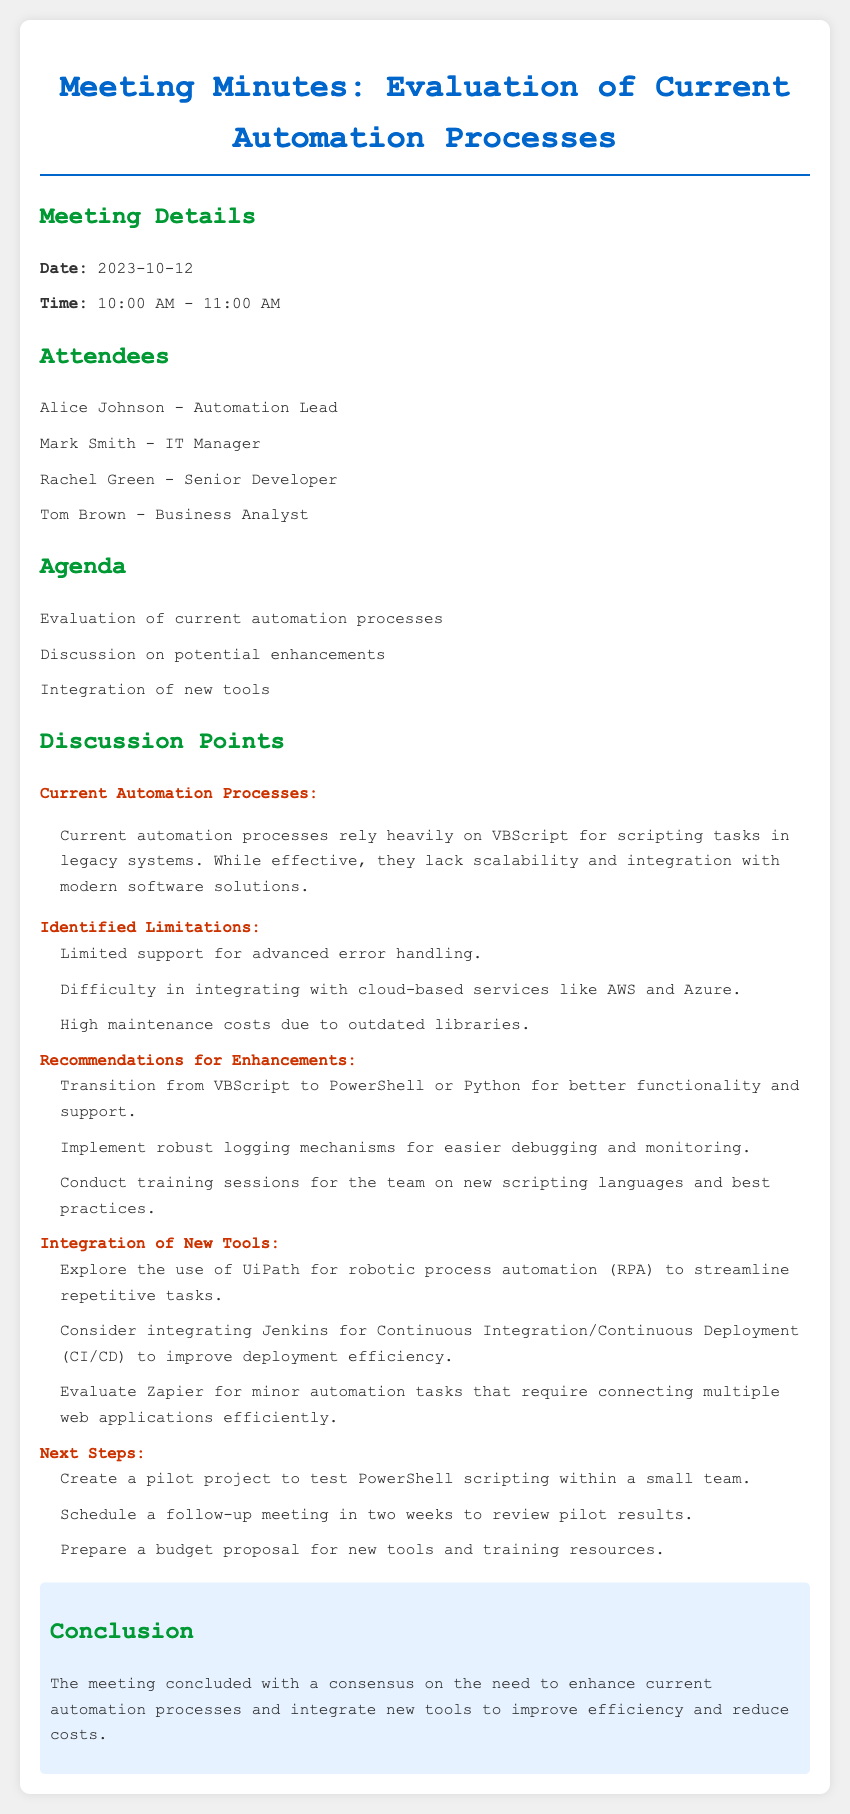what was the date of the meeting? The date of the meeting is specified in the document under Meeting Details.
Answer: 2023-10-12 who is the Automation Lead? The document lists the attendees, including their roles.
Answer: Alice Johnson what is a limitation of the current automation processes? Limitations are outlined under Identified Limitations in the document.
Answer: Limited support for advanced error handling what new tool is suggested for robotic process automation? The document mentions potential new tools for integration.
Answer: UiPath how many attendees were present in the meeting? The number of attendees can be counted from the Attendees section of the document.
Answer: 4 what scripting languages are recommended for transition? Recommendations for enhancements include specific scripting languages.
Answer: PowerShell or Python when is the follow-up meeting scheduled? The document notes the next steps, including when the follow-up will occur.
Answer: In two weeks what is a suggested improvement for debugging? The recommendations under Enhancements include suggestions for debugging improvements.
Answer: Implement robust logging mechanisms 